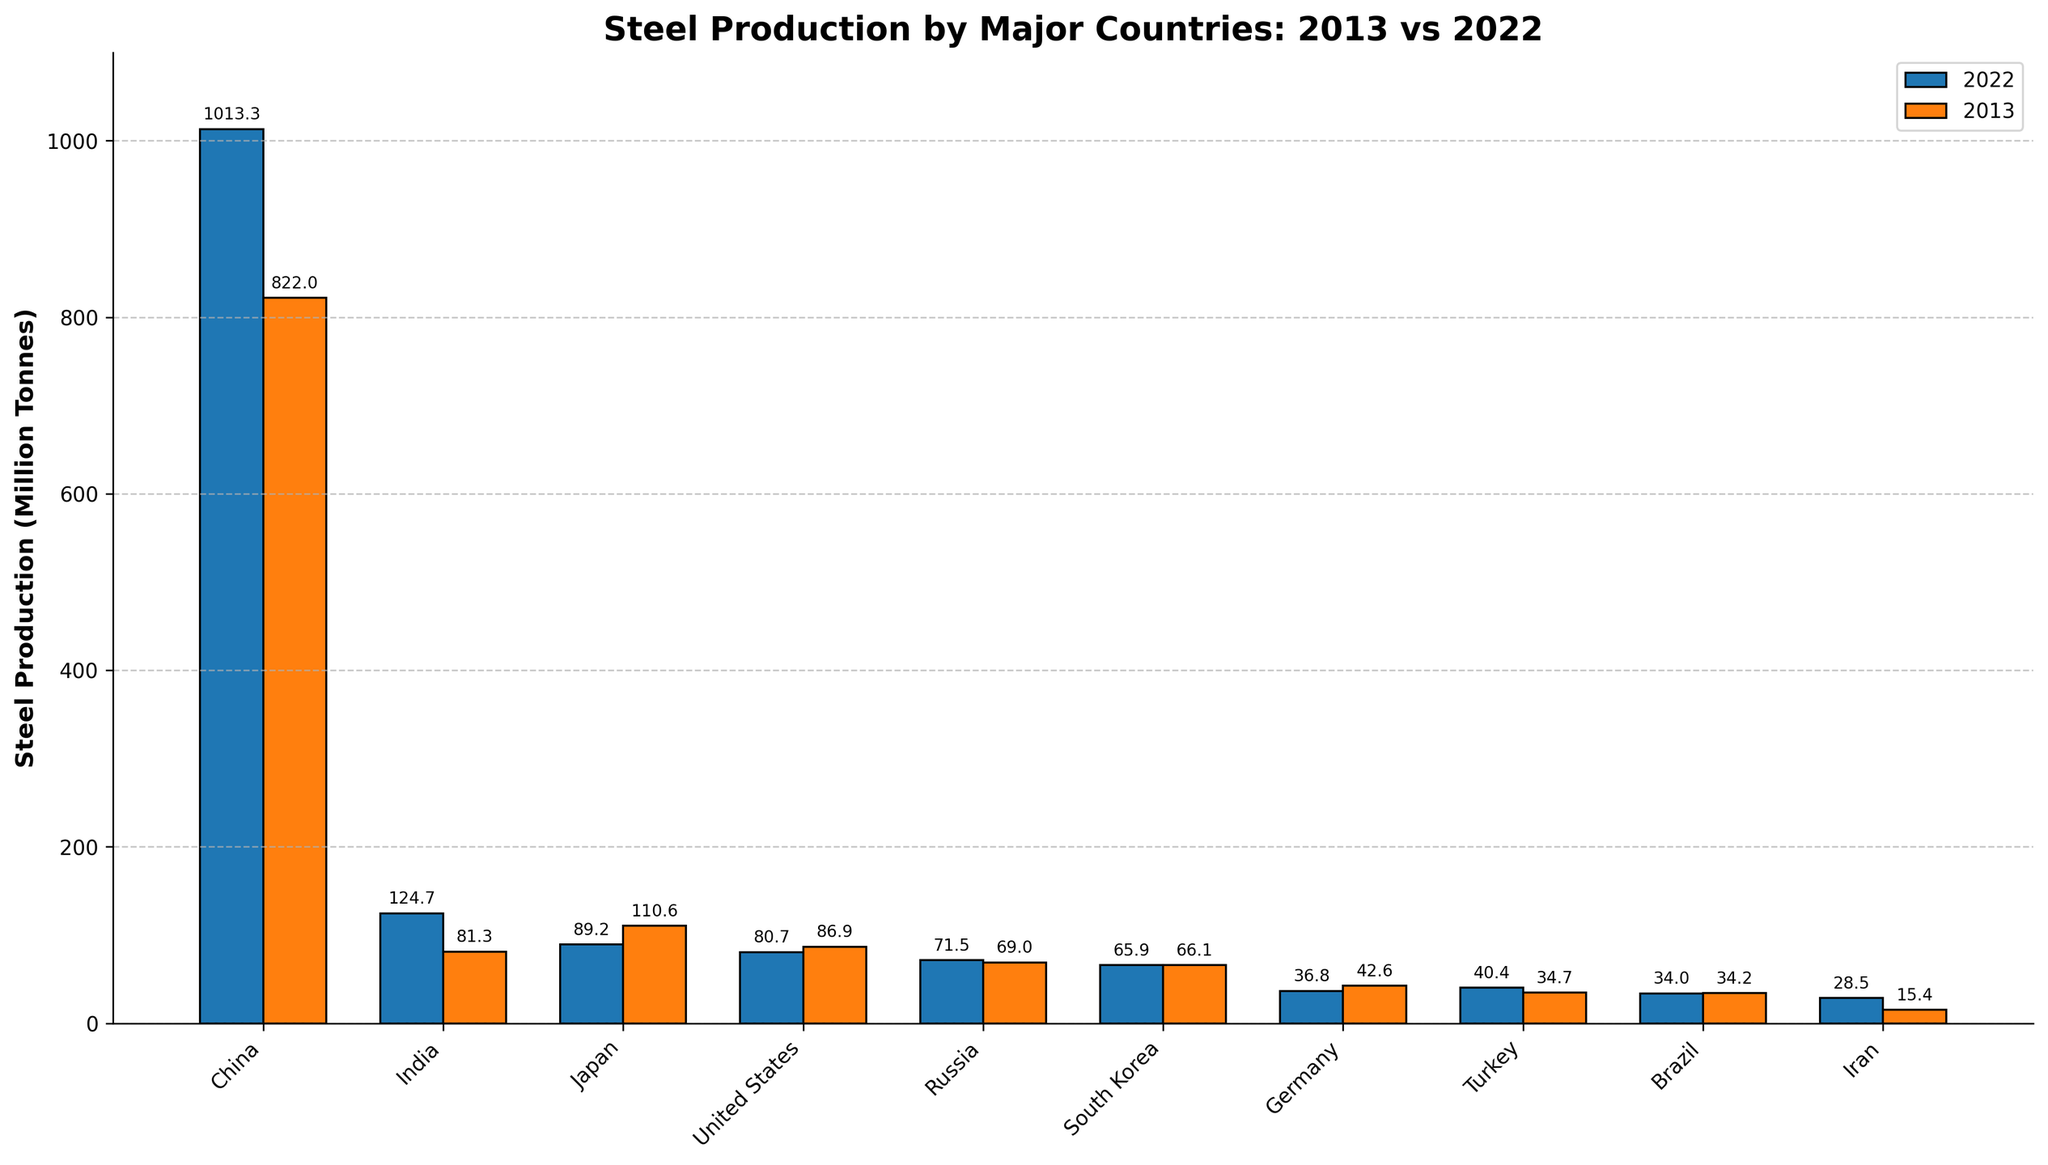How much did China's steel production increase from 2013 to 2022? To find the increase, subtract the value for 2013 from the value for 2022. So, 1013.3 (2022) - 822.0 (2013) = 191.3.
Answer: 191.3 million tonnes Which country had the highest steel production in 2022? Observing the height of the bars for 2022, China has the highest bar, indicating it produced the most steel.
Answer: China Compare Japan's steel production in 2013 and 2022. Did it increase or decrease, and by how much? Subtract Japan's 2022 value from its 2013 value: 110.6 (2013) - 89.2 (2022) = 21.4. The negative result indicates a decrease.
Answer: Decrease by 21.4 million tonnes Of the listed countries, which has the smallest change in steel production from 2013 to 2022? Calculate the absolute change for each country between 2013 and 2022. The smallest change is in Russia: abs(71.5 - 69.0) = 2.5.
Answer: Russia Which countries produced more than 100 million tonnes of steel in 2022? Identify the countries from the 2022 bars that exceed 100 million tonnes. These countries are China and India.
Answer: China and India Between 2013 and 2022, which country's steel production grew the fastest in percentage terms? Calculate the percentage increase for each country. For Iran: ((28.5 - 15.4) / 15.4) * 100 = 85.1%. This is the highest percentage increase among the countries.
Answer: Iran How does India's steel production in 2022 compare to that in 2013? Observe the bars for India in 2022 and 2013 and identify that the 2022 bar is higher. To quantify: 124.7 (2022) - 81.3 (2013) = 43.4 million tonnes increase.
Answer: Increase by 43.4 million tonnes Which country showed a drop in steel production in 2022 compared to 2013 while others increased? Comparing the bars for 2022 and 2013, Germany shows a drop: from 42.6 (2013) to 36.8 (2022).
Answer: Germany What is the combined steel production of Turkey and Brazil in 2022, and how does it compare to China's 2022 production? Add Turkey and Brazil's 2022 values: 40.4 + 34.0 = 74.4. Compare this with China: 74.4 is much less than 1013.3.
Answer: Combined is 74.4, much less than China What general trend do you notice in the steel production of most countries from 2013 to 2022? Generally, China's and India's production increased significantly, while other countries showed mixed trends with small increases or decreases.
Answer: Mixed trends, notable increases in China and India 